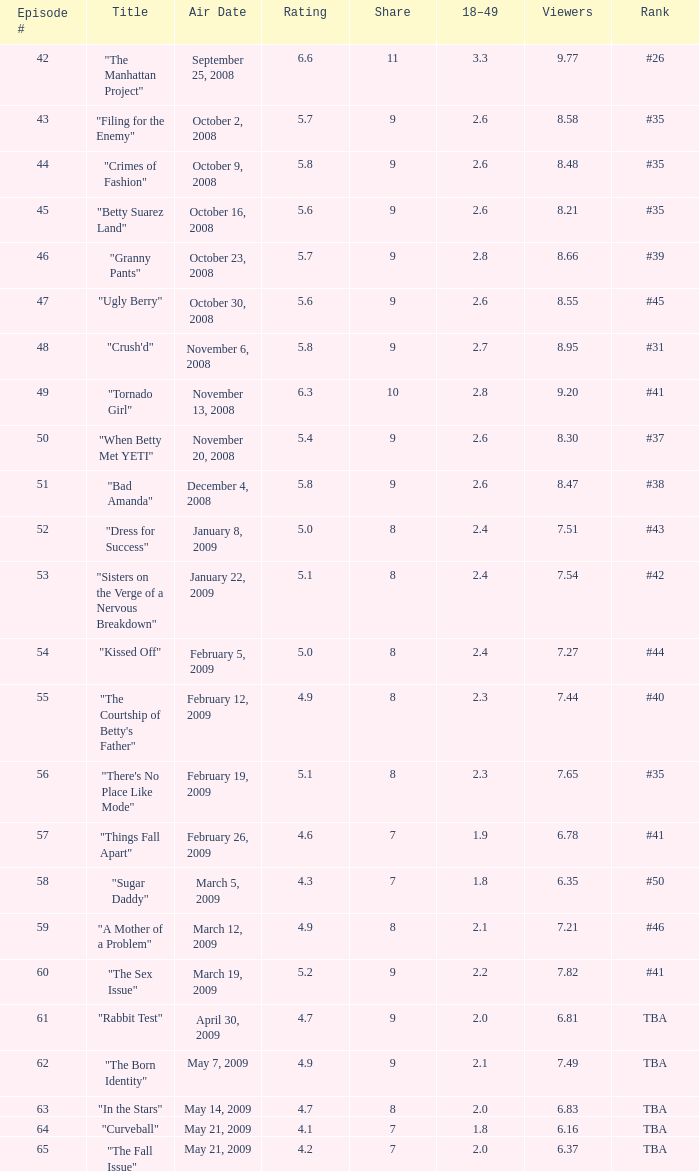What is the least amount of viewers for an episode numbered above 58, named "curveball" and having a rating under None. 